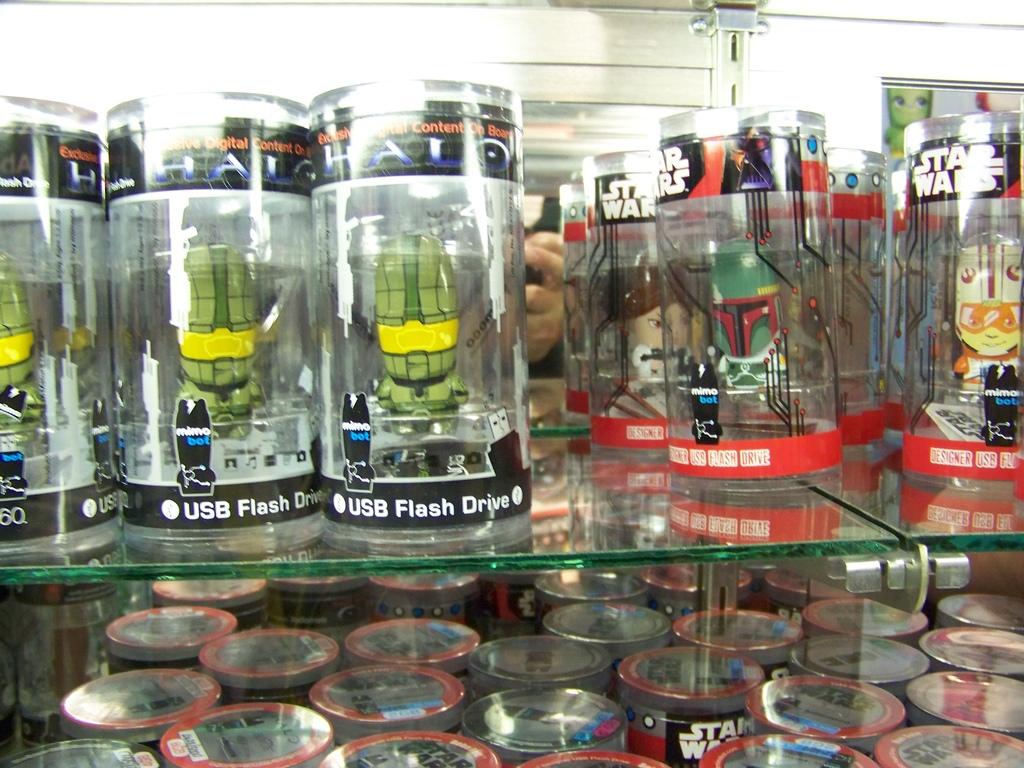What kind of product is in the clear tubes?
Your answer should be compact. Usb flash drive. What is the brand of the usb on the left?
Your answer should be very brief. Halo. 